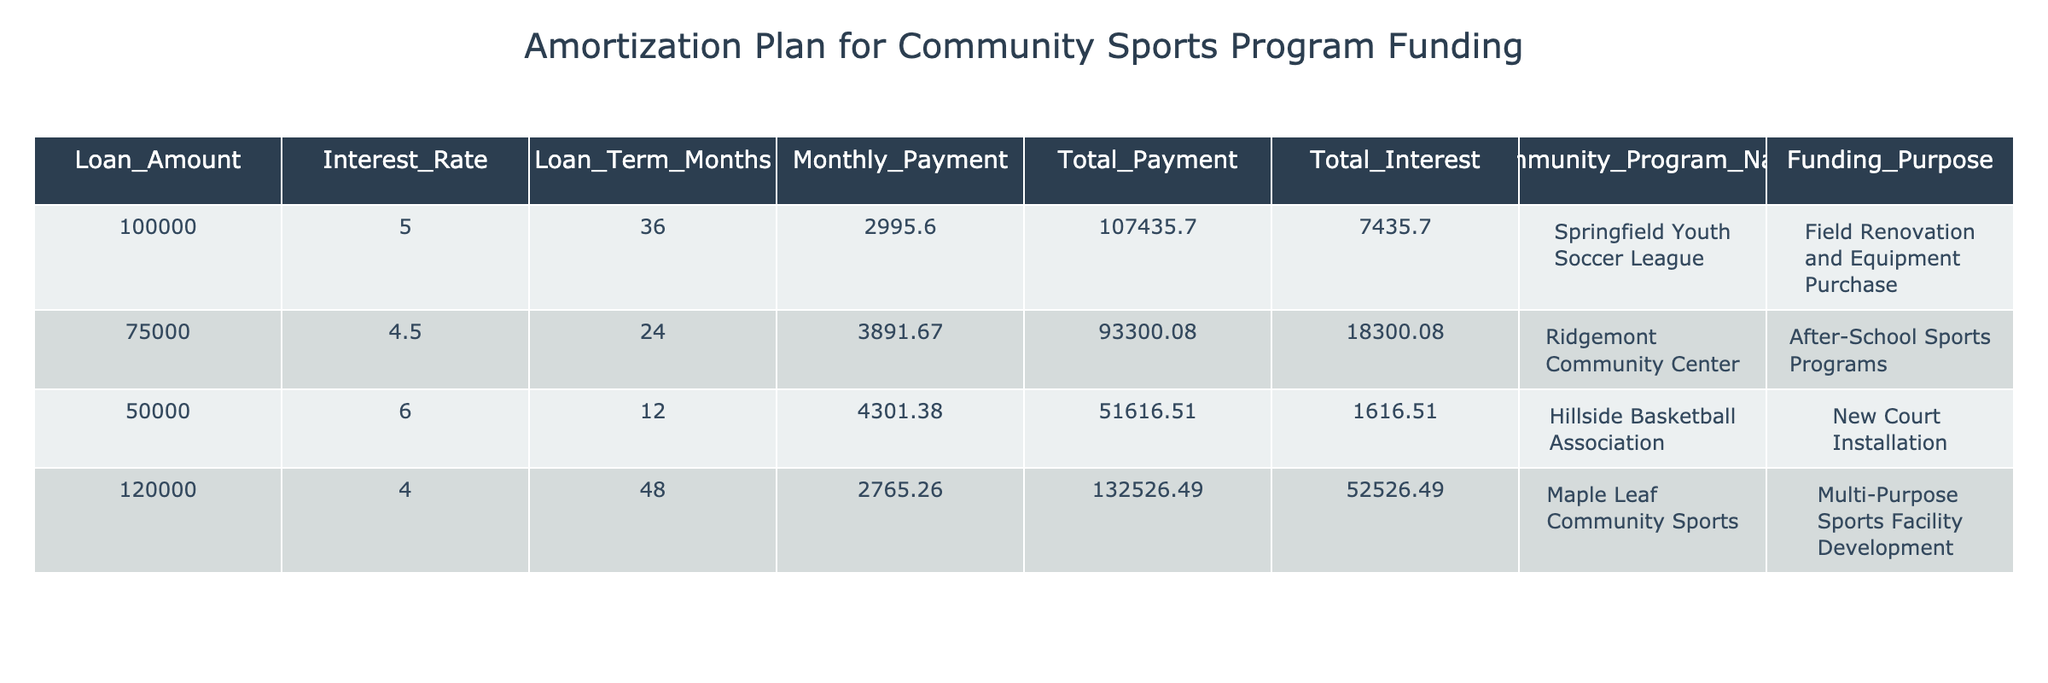What is the loan amount for the Springfield Youth Soccer League? The loan amount is clearly listed in the table under the "Loan_Amount" column next to the corresponding community program name. For the Springfield Youth Soccer League, the amount is 100000.
Answer: 100000 What is the total interest paid for the Hillside Basketball Association? To find the total interest for the Hillside Basketball Association, we can look at the "Total_Interest" column corresponding to that program. It shows a total interest of 1616.51.
Answer: 1616.51 What is the monthly payment for the Ridgemont Community Center? The monthly payment can be found in the "Monthly_Payment" column in the table. For the Ridgemont Community Center, the monthly payment is 3891.67.
Answer: 3891.67 Is the total payment for the Maple Leaf Community Sports greater than 130000? We need to check the "Total_Payment" value for Maple Leaf Community Sports, which is listed as 132526.49. This is greater than 130000. Therefore, the answer is true.
Answer: Yes What is the difference in total payment between the Springfield Youth Soccer League and the Maple Leaf Community Sports? First, identify the total payment for both programs. Springfield Youth Soccer League has a total payment of 107435.70 and Maple Leaf Community Sports has a total payment of 132526.49. The difference is calculated as 132526.49 - 107435.70 = 25090.79.
Answer: 25090.79 Which community program has the lowest interest rate? In the table, we need to compare the "Interest_Rate" column for all programs. The lowest rate is 4.0%, associated with the Maple Leaf Community Sports.
Answer: Maple Leaf Community Sports If the loan term for the Hillside Basketball Association was extended by 6 months, what would the new loan term be? The current loan term for the Hillside Basketball Association is 12 months. If we extend it by 6 months, we add 6 to 12, resulting in a new loan term of 18 months.
Answer: 18 months Are there any community programs with a loan amount of 50000 or less? We review the "Loan_Amount" column to check for any values equal to or below 50000. The Hillside Basketball Association has a loan amount of 50000, so the answer is true.
Answer: Yes What is the average total payment amount across all community programs in the table? First, we calculate the total payment amounts: 107435.70 + 93300.08 + 51616.51 + 132526.49 = 414878.78. There are 4 programs, so we divide the total by 4: 414878.78 / 4 = 103719.695. Thus, the average is approximately 103719.70.
Answer: 103719.70 